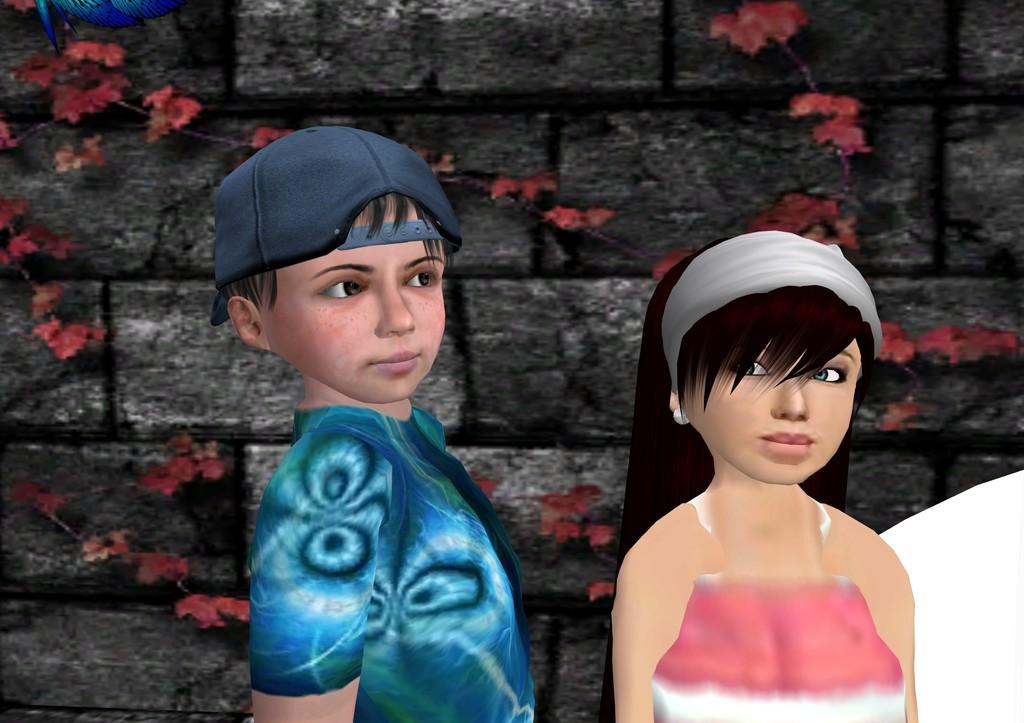What type of media is the image? The image is an animation. Who are the characters in the image? There is a boy and a girl in the image. What is in the background of the image? There is a wall in the image. What is on the wall in the image? Creepers are present on the wall. What type of bird can be seen singing on the girl's shoulder in the image? There is no bird present on the girl's shoulder in the image. 